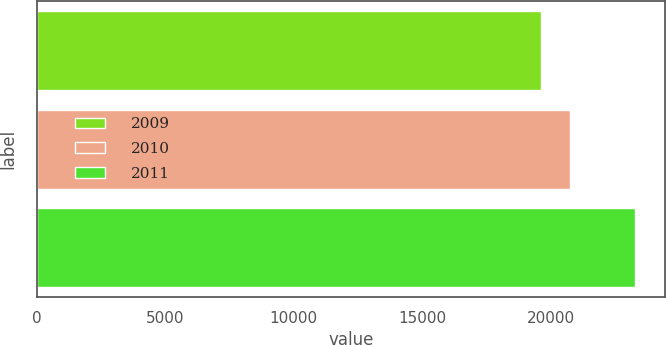<chart> <loc_0><loc_0><loc_500><loc_500><bar_chart><fcel>2009<fcel>2010<fcel>2011<nl><fcel>19595<fcel>20747<fcel>23277<nl></chart> 